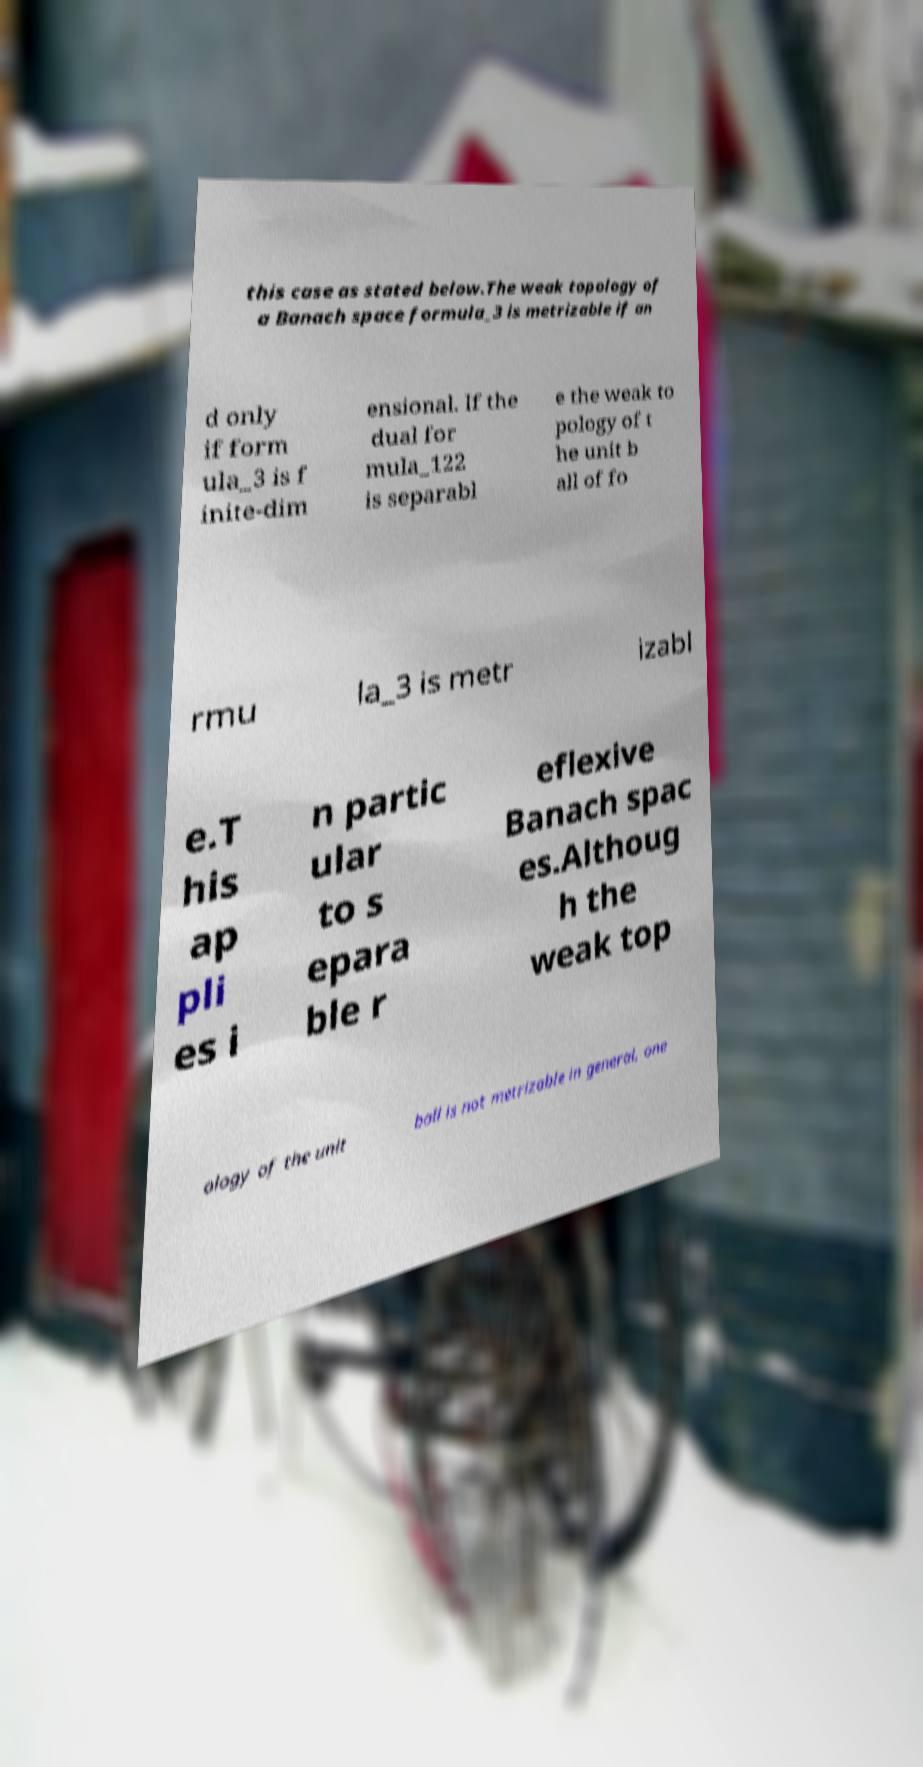Could you extract and type out the text from this image? this case as stated below.The weak topology of a Banach space formula_3 is metrizable if an d only if form ula_3 is f inite-dim ensional. If the dual for mula_122 is separabl e the weak to pology of t he unit b all of fo rmu la_3 is metr izabl e.T his ap pli es i n partic ular to s epara ble r eflexive Banach spac es.Althoug h the weak top ology of the unit ball is not metrizable in general, one 